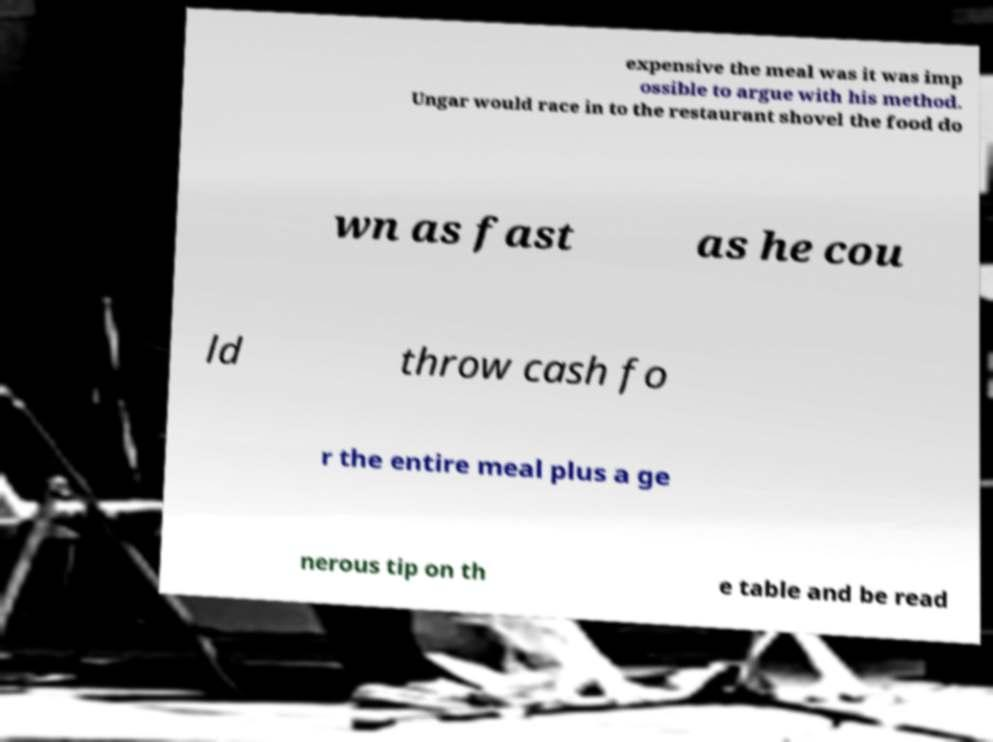Please read and relay the text visible in this image. What does it say? expensive the meal was it was imp ossible to argue with his method. Ungar would race in to the restaurant shovel the food do wn as fast as he cou ld throw cash fo r the entire meal plus a ge nerous tip on th e table and be read 